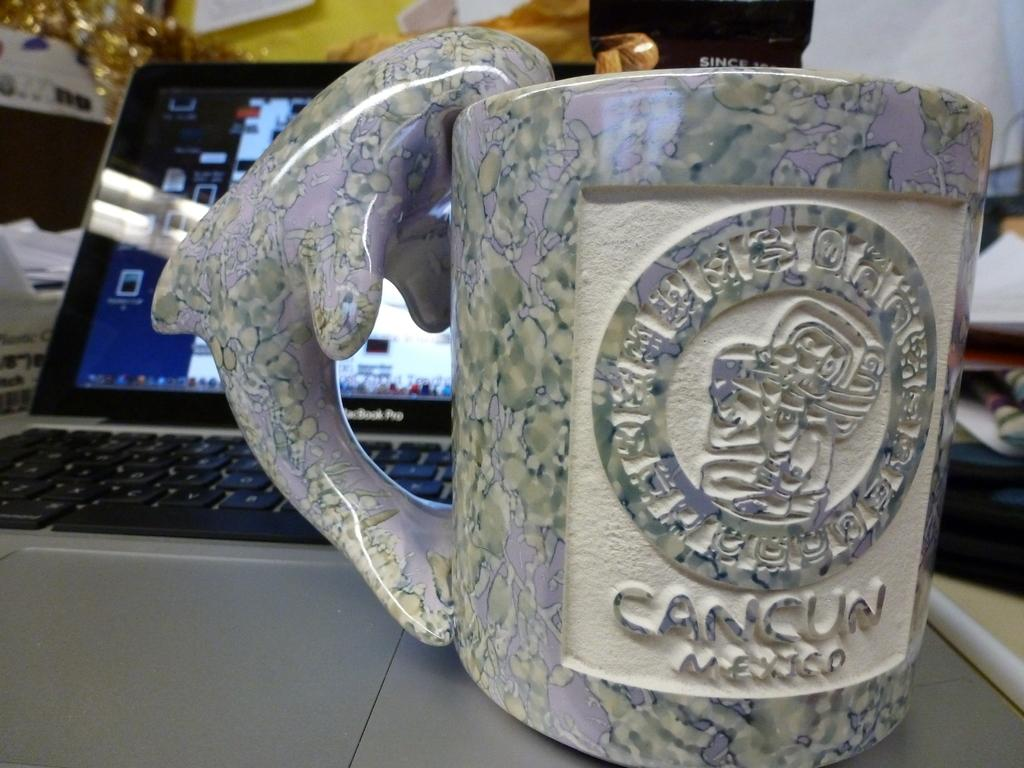<image>
Share a concise interpretation of the image provided. A mug with a dolphin handle says Cancun Mexico on it. 